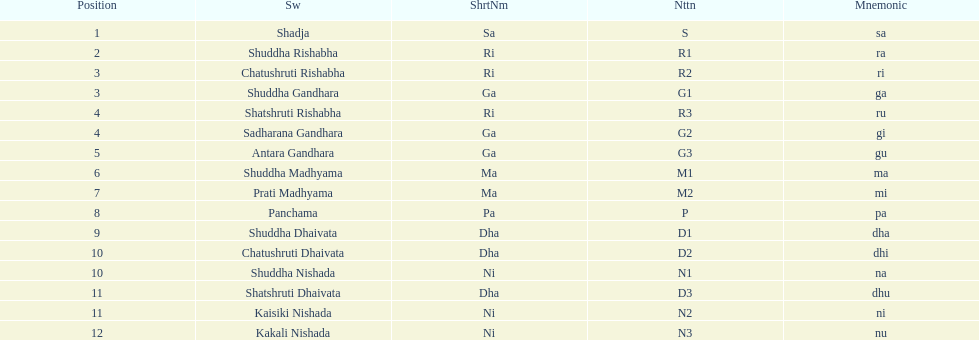Find the 9th position swara. what is its short name? Dha. 